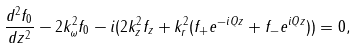<formula> <loc_0><loc_0><loc_500><loc_500>\frac { d ^ { 2 } f _ { 0 } } { d z ^ { 2 } } - 2 k _ { \omega } ^ { 2 } f _ { 0 } - i ( 2 k _ { z } ^ { 2 } f _ { z } + k _ { r } ^ { 2 } ( f _ { + } e ^ { - i Q z } + f _ { - } e ^ { i Q z } ) ) = 0 ,</formula> 